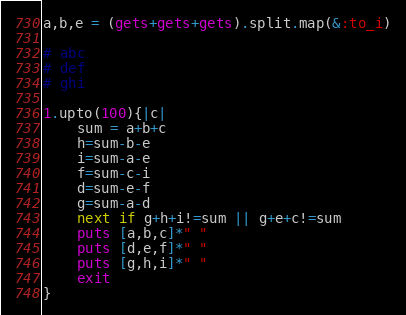Convert code to text. <code><loc_0><loc_0><loc_500><loc_500><_Ruby_>a,b,e = (gets+gets+gets).split.map(&:to_i)

# abc
# def
# ghi

1.upto(100){|c|
    sum = a+b+c
    h=sum-b-e
    i=sum-a-e
    f=sum-c-i
    d=sum-e-f
    g=sum-a-d
    next if g+h+i!=sum || g+e+c!=sum
    puts [a,b,c]*" "
    puts [d,e,f]*" "
    puts [g,h,i]*" "
    exit
}</code> 